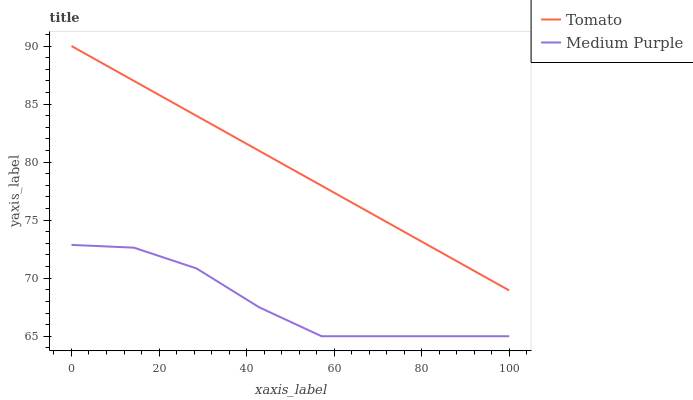Does Medium Purple have the minimum area under the curve?
Answer yes or no. Yes. Does Tomato have the maximum area under the curve?
Answer yes or no. Yes. Does Medium Purple have the maximum area under the curve?
Answer yes or no. No. Is Tomato the smoothest?
Answer yes or no. Yes. Is Medium Purple the roughest?
Answer yes or no. Yes. Is Medium Purple the smoothest?
Answer yes or no. No. Does Medium Purple have the lowest value?
Answer yes or no. Yes. Does Tomato have the highest value?
Answer yes or no. Yes. Does Medium Purple have the highest value?
Answer yes or no. No. Is Medium Purple less than Tomato?
Answer yes or no. Yes. Is Tomato greater than Medium Purple?
Answer yes or no. Yes. Does Medium Purple intersect Tomato?
Answer yes or no. No. 